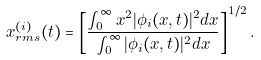Convert formula to latex. <formula><loc_0><loc_0><loc_500><loc_500>x ^ { ( i ) } _ { r m s } ( t ) = \left [ \frac { \int _ { 0 } ^ { \infty } x ^ { 2 } | \phi _ { i } ( x , t ) | ^ { 2 } d x } { \int _ { 0 } ^ { \infty } | \phi _ { i } ( x , t ) | ^ { 2 } d x } \right ] ^ { 1 / 2 } .</formula> 